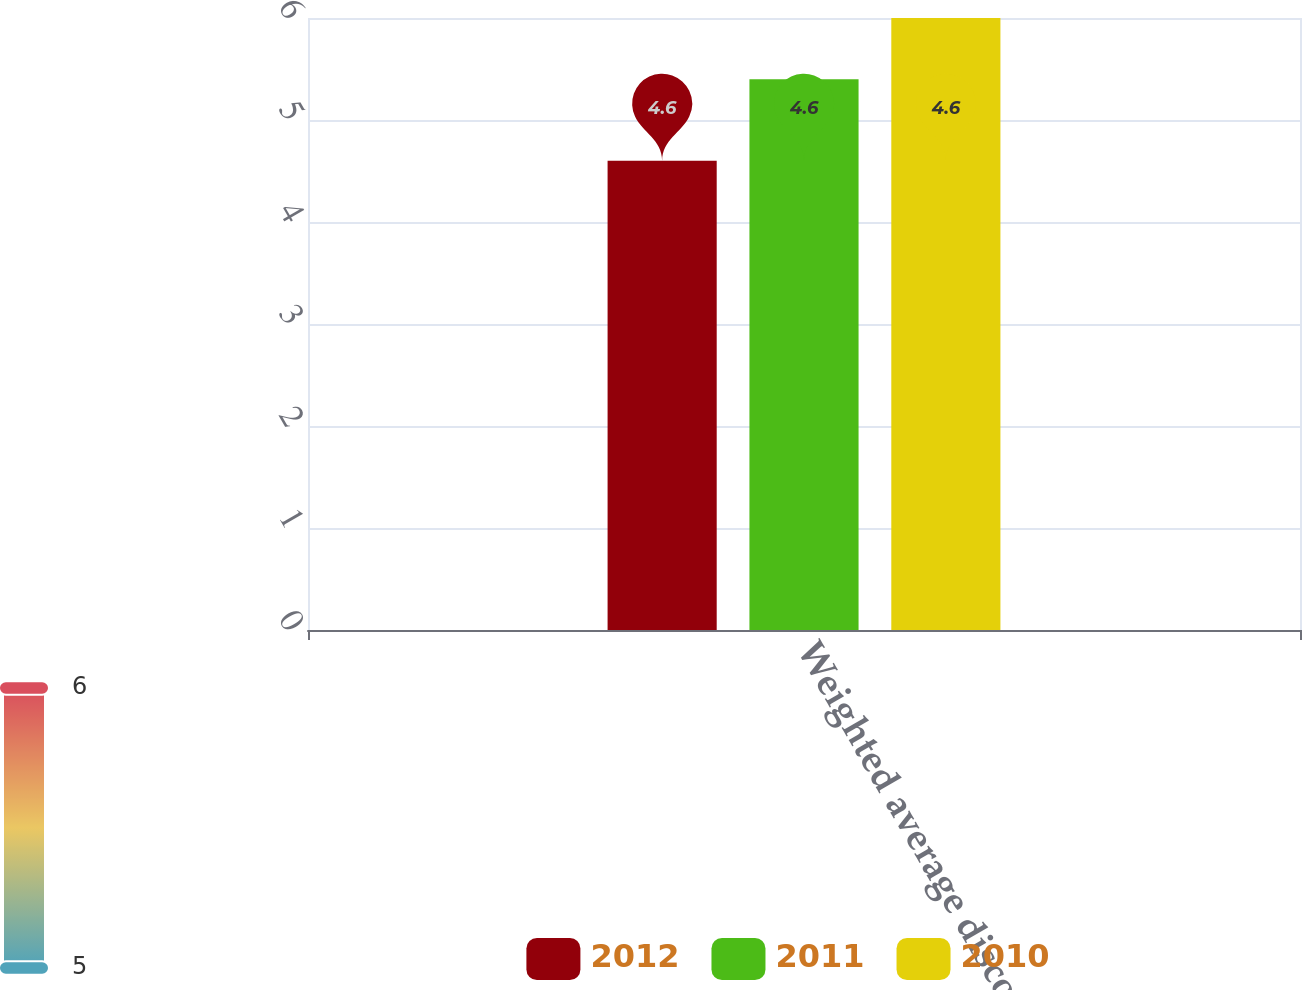<chart> <loc_0><loc_0><loc_500><loc_500><stacked_bar_chart><ecel><fcel>Weighted average discount<nl><fcel>2012<fcel>4.6<nl><fcel>2011<fcel>5.4<nl><fcel>2010<fcel>6<nl></chart> 